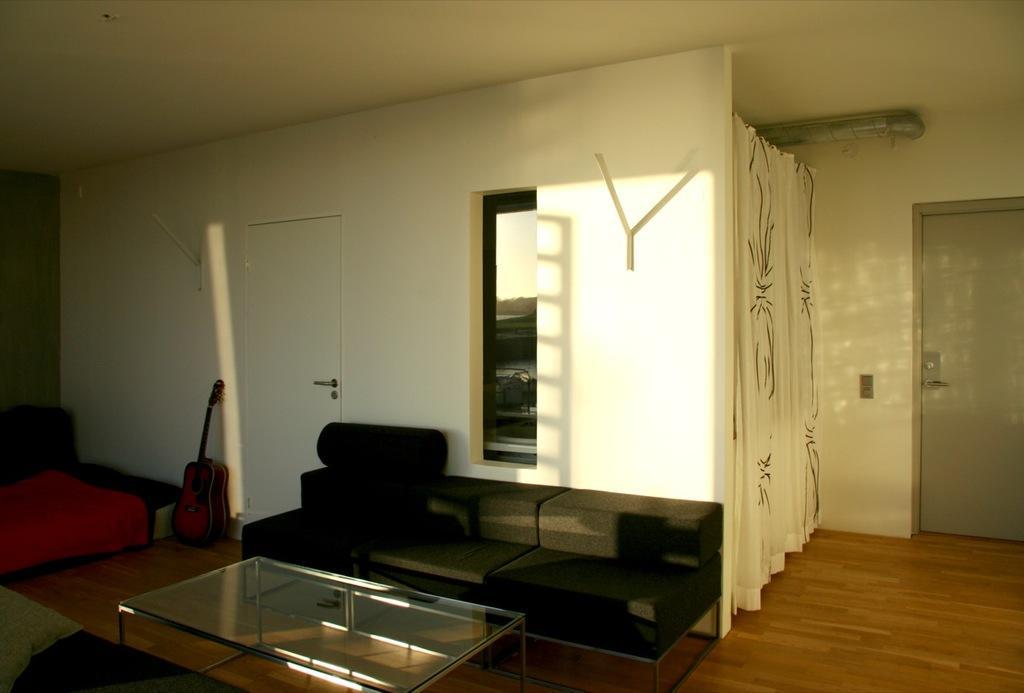How would you summarize this image in a sentence or two? This is a picture of a living room where we have door, couch , table ,pillow, carpet , guitar , pipe , curtain. 